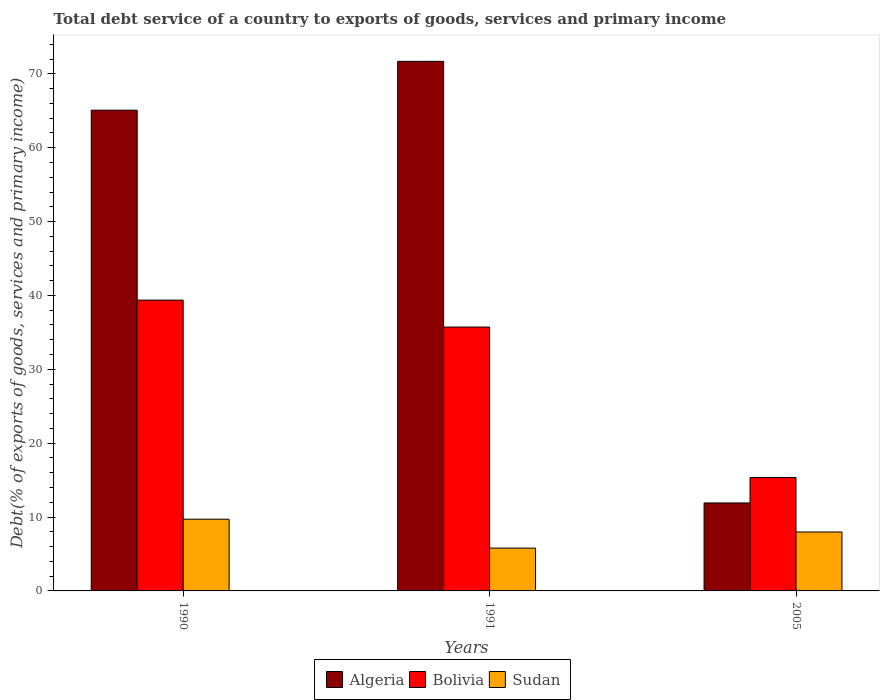How many different coloured bars are there?
Your response must be concise. 3. Are the number of bars per tick equal to the number of legend labels?
Provide a short and direct response. Yes. How many bars are there on the 3rd tick from the right?
Keep it short and to the point. 3. In how many cases, is the number of bars for a given year not equal to the number of legend labels?
Provide a succinct answer. 0. What is the total debt service in Sudan in 2005?
Your response must be concise. 7.98. Across all years, what is the maximum total debt service in Algeria?
Your answer should be compact. 71.69. Across all years, what is the minimum total debt service in Algeria?
Provide a short and direct response. 11.91. What is the total total debt service in Bolivia in the graph?
Offer a terse response. 90.44. What is the difference between the total debt service in Bolivia in 1990 and that in 2005?
Make the answer very short. 24.01. What is the difference between the total debt service in Sudan in 2005 and the total debt service in Bolivia in 1990?
Your answer should be compact. -31.39. What is the average total debt service in Sudan per year?
Your answer should be compact. 7.83. In the year 2005, what is the difference between the total debt service in Sudan and total debt service in Bolivia?
Give a very brief answer. -7.38. What is the ratio of the total debt service in Algeria in 1991 to that in 2005?
Give a very brief answer. 6.02. Is the total debt service in Bolivia in 1991 less than that in 2005?
Give a very brief answer. No. Is the difference between the total debt service in Sudan in 1991 and 2005 greater than the difference between the total debt service in Bolivia in 1991 and 2005?
Your response must be concise. No. What is the difference between the highest and the second highest total debt service in Sudan?
Your answer should be very brief. 1.73. What is the difference between the highest and the lowest total debt service in Bolivia?
Provide a succinct answer. 24.01. In how many years, is the total debt service in Sudan greater than the average total debt service in Sudan taken over all years?
Your answer should be compact. 2. Is the sum of the total debt service in Sudan in 1990 and 2005 greater than the maximum total debt service in Bolivia across all years?
Offer a very short reply. No. What does the 2nd bar from the left in 2005 represents?
Provide a short and direct response. Bolivia. What does the 1st bar from the right in 2005 represents?
Ensure brevity in your answer.  Sudan. How many bars are there?
Ensure brevity in your answer.  9. Does the graph contain grids?
Provide a succinct answer. No. What is the title of the graph?
Your answer should be compact. Total debt service of a country to exports of goods, services and primary income. What is the label or title of the X-axis?
Ensure brevity in your answer.  Years. What is the label or title of the Y-axis?
Give a very brief answer. Debt(% of exports of goods, services and primary income). What is the Debt(% of exports of goods, services and primary income) of Algeria in 1990?
Keep it short and to the point. 65.08. What is the Debt(% of exports of goods, services and primary income) of Bolivia in 1990?
Give a very brief answer. 39.37. What is the Debt(% of exports of goods, services and primary income) of Sudan in 1990?
Provide a short and direct response. 9.71. What is the Debt(% of exports of goods, services and primary income) of Algeria in 1991?
Provide a short and direct response. 71.69. What is the Debt(% of exports of goods, services and primary income) in Bolivia in 1991?
Your answer should be very brief. 35.72. What is the Debt(% of exports of goods, services and primary income) in Sudan in 1991?
Your answer should be compact. 5.8. What is the Debt(% of exports of goods, services and primary income) of Algeria in 2005?
Offer a very short reply. 11.91. What is the Debt(% of exports of goods, services and primary income) in Bolivia in 2005?
Offer a very short reply. 15.35. What is the Debt(% of exports of goods, services and primary income) in Sudan in 2005?
Your response must be concise. 7.98. Across all years, what is the maximum Debt(% of exports of goods, services and primary income) in Algeria?
Provide a succinct answer. 71.69. Across all years, what is the maximum Debt(% of exports of goods, services and primary income) in Bolivia?
Make the answer very short. 39.37. Across all years, what is the maximum Debt(% of exports of goods, services and primary income) of Sudan?
Make the answer very short. 9.71. Across all years, what is the minimum Debt(% of exports of goods, services and primary income) in Algeria?
Your answer should be very brief. 11.91. Across all years, what is the minimum Debt(% of exports of goods, services and primary income) in Bolivia?
Make the answer very short. 15.35. Across all years, what is the minimum Debt(% of exports of goods, services and primary income) in Sudan?
Offer a terse response. 5.8. What is the total Debt(% of exports of goods, services and primary income) of Algeria in the graph?
Provide a short and direct response. 148.68. What is the total Debt(% of exports of goods, services and primary income) in Bolivia in the graph?
Keep it short and to the point. 90.44. What is the total Debt(% of exports of goods, services and primary income) in Sudan in the graph?
Provide a short and direct response. 23.49. What is the difference between the Debt(% of exports of goods, services and primary income) in Algeria in 1990 and that in 1991?
Offer a terse response. -6.61. What is the difference between the Debt(% of exports of goods, services and primary income) of Bolivia in 1990 and that in 1991?
Keep it short and to the point. 3.65. What is the difference between the Debt(% of exports of goods, services and primary income) in Sudan in 1990 and that in 1991?
Your answer should be compact. 3.91. What is the difference between the Debt(% of exports of goods, services and primary income) of Algeria in 1990 and that in 2005?
Make the answer very short. 53.17. What is the difference between the Debt(% of exports of goods, services and primary income) in Bolivia in 1990 and that in 2005?
Your response must be concise. 24.01. What is the difference between the Debt(% of exports of goods, services and primary income) in Sudan in 1990 and that in 2005?
Your answer should be very brief. 1.73. What is the difference between the Debt(% of exports of goods, services and primary income) in Algeria in 1991 and that in 2005?
Give a very brief answer. 59.78. What is the difference between the Debt(% of exports of goods, services and primary income) of Bolivia in 1991 and that in 2005?
Your response must be concise. 20.37. What is the difference between the Debt(% of exports of goods, services and primary income) in Sudan in 1991 and that in 2005?
Keep it short and to the point. -2.18. What is the difference between the Debt(% of exports of goods, services and primary income) of Algeria in 1990 and the Debt(% of exports of goods, services and primary income) of Bolivia in 1991?
Provide a short and direct response. 29.36. What is the difference between the Debt(% of exports of goods, services and primary income) in Algeria in 1990 and the Debt(% of exports of goods, services and primary income) in Sudan in 1991?
Offer a terse response. 59.28. What is the difference between the Debt(% of exports of goods, services and primary income) of Bolivia in 1990 and the Debt(% of exports of goods, services and primary income) of Sudan in 1991?
Give a very brief answer. 33.57. What is the difference between the Debt(% of exports of goods, services and primary income) of Algeria in 1990 and the Debt(% of exports of goods, services and primary income) of Bolivia in 2005?
Make the answer very short. 49.72. What is the difference between the Debt(% of exports of goods, services and primary income) in Algeria in 1990 and the Debt(% of exports of goods, services and primary income) in Sudan in 2005?
Give a very brief answer. 57.1. What is the difference between the Debt(% of exports of goods, services and primary income) in Bolivia in 1990 and the Debt(% of exports of goods, services and primary income) in Sudan in 2005?
Ensure brevity in your answer.  31.39. What is the difference between the Debt(% of exports of goods, services and primary income) of Algeria in 1991 and the Debt(% of exports of goods, services and primary income) of Bolivia in 2005?
Offer a terse response. 56.34. What is the difference between the Debt(% of exports of goods, services and primary income) in Algeria in 1991 and the Debt(% of exports of goods, services and primary income) in Sudan in 2005?
Provide a short and direct response. 63.71. What is the difference between the Debt(% of exports of goods, services and primary income) of Bolivia in 1991 and the Debt(% of exports of goods, services and primary income) of Sudan in 2005?
Provide a short and direct response. 27.75. What is the average Debt(% of exports of goods, services and primary income) of Algeria per year?
Offer a very short reply. 49.56. What is the average Debt(% of exports of goods, services and primary income) of Bolivia per year?
Give a very brief answer. 30.15. What is the average Debt(% of exports of goods, services and primary income) of Sudan per year?
Ensure brevity in your answer.  7.83. In the year 1990, what is the difference between the Debt(% of exports of goods, services and primary income) of Algeria and Debt(% of exports of goods, services and primary income) of Bolivia?
Provide a succinct answer. 25.71. In the year 1990, what is the difference between the Debt(% of exports of goods, services and primary income) of Algeria and Debt(% of exports of goods, services and primary income) of Sudan?
Keep it short and to the point. 55.37. In the year 1990, what is the difference between the Debt(% of exports of goods, services and primary income) of Bolivia and Debt(% of exports of goods, services and primary income) of Sudan?
Keep it short and to the point. 29.66. In the year 1991, what is the difference between the Debt(% of exports of goods, services and primary income) in Algeria and Debt(% of exports of goods, services and primary income) in Bolivia?
Your answer should be compact. 35.97. In the year 1991, what is the difference between the Debt(% of exports of goods, services and primary income) in Algeria and Debt(% of exports of goods, services and primary income) in Sudan?
Keep it short and to the point. 65.89. In the year 1991, what is the difference between the Debt(% of exports of goods, services and primary income) of Bolivia and Debt(% of exports of goods, services and primary income) of Sudan?
Keep it short and to the point. 29.92. In the year 2005, what is the difference between the Debt(% of exports of goods, services and primary income) in Algeria and Debt(% of exports of goods, services and primary income) in Bolivia?
Your answer should be very brief. -3.44. In the year 2005, what is the difference between the Debt(% of exports of goods, services and primary income) of Algeria and Debt(% of exports of goods, services and primary income) of Sudan?
Provide a succinct answer. 3.93. In the year 2005, what is the difference between the Debt(% of exports of goods, services and primary income) in Bolivia and Debt(% of exports of goods, services and primary income) in Sudan?
Provide a succinct answer. 7.38. What is the ratio of the Debt(% of exports of goods, services and primary income) of Algeria in 1990 to that in 1991?
Give a very brief answer. 0.91. What is the ratio of the Debt(% of exports of goods, services and primary income) in Bolivia in 1990 to that in 1991?
Provide a succinct answer. 1.1. What is the ratio of the Debt(% of exports of goods, services and primary income) in Sudan in 1990 to that in 1991?
Give a very brief answer. 1.68. What is the ratio of the Debt(% of exports of goods, services and primary income) of Algeria in 1990 to that in 2005?
Provide a succinct answer. 5.46. What is the ratio of the Debt(% of exports of goods, services and primary income) in Bolivia in 1990 to that in 2005?
Offer a terse response. 2.56. What is the ratio of the Debt(% of exports of goods, services and primary income) of Sudan in 1990 to that in 2005?
Keep it short and to the point. 1.22. What is the ratio of the Debt(% of exports of goods, services and primary income) in Algeria in 1991 to that in 2005?
Offer a very short reply. 6.02. What is the ratio of the Debt(% of exports of goods, services and primary income) in Bolivia in 1991 to that in 2005?
Your response must be concise. 2.33. What is the ratio of the Debt(% of exports of goods, services and primary income) of Sudan in 1991 to that in 2005?
Keep it short and to the point. 0.73. What is the difference between the highest and the second highest Debt(% of exports of goods, services and primary income) in Algeria?
Offer a terse response. 6.61. What is the difference between the highest and the second highest Debt(% of exports of goods, services and primary income) of Bolivia?
Keep it short and to the point. 3.65. What is the difference between the highest and the second highest Debt(% of exports of goods, services and primary income) in Sudan?
Offer a very short reply. 1.73. What is the difference between the highest and the lowest Debt(% of exports of goods, services and primary income) of Algeria?
Provide a succinct answer. 59.78. What is the difference between the highest and the lowest Debt(% of exports of goods, services and primary income) of Bolivia?
Your answer should be very brief. 24.01. What is the difference between the highest and the lowest Debt(% of exports of goods, services and primary income) of Sudan?
Provide a succinct answer. 3.91. 